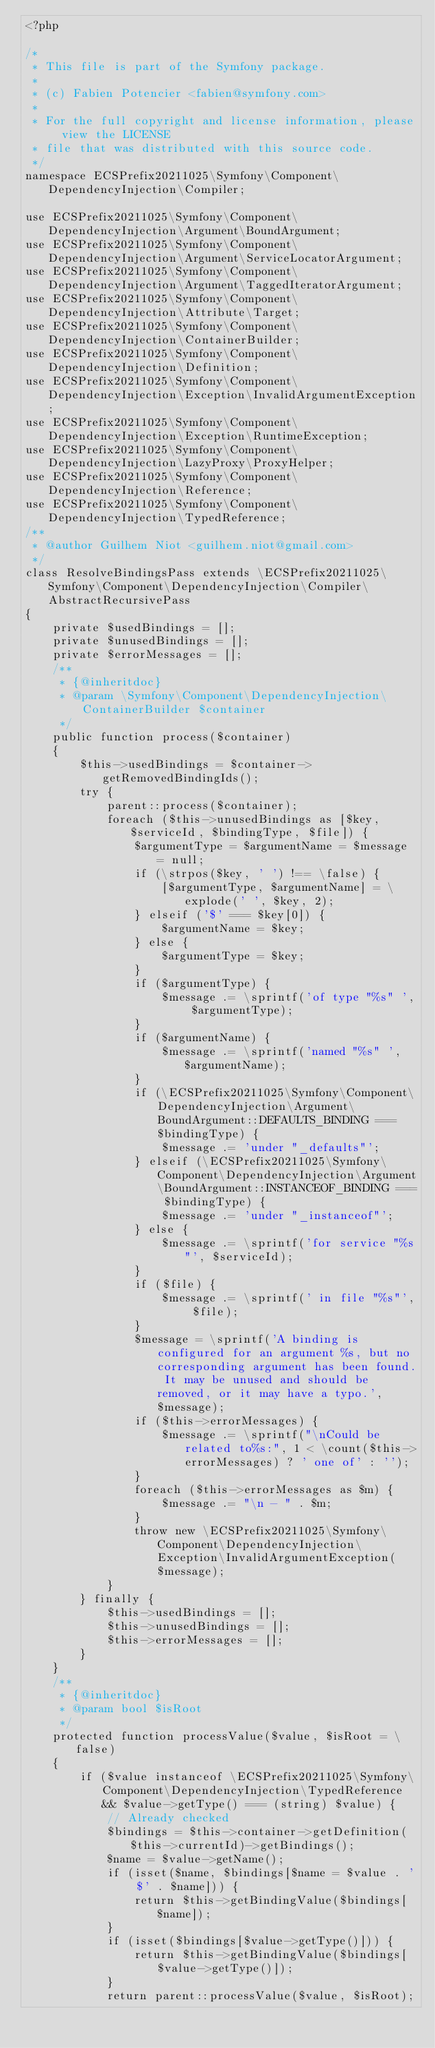Convert code to text. <code><loc_0><loc_0><loc_500><loc_500><_PHP_><?php

/*
 * This file is part of the Symfony package.
 *
 * (c) Fabien Potencier <fabien@symfony.com>
 *
 * For the full copyright and license information, please view the LICENSE
 * file that was distributed with this source code.
 */
namespace ECSPrefix20211025\Symfony\Component\DependencyInjection\Compiler;

use ECSPrefix20211025\Symfony\Component\DependencyInjection\Argument\BoundArgument;
use ECSPrefix20211025\Symfony\Component\DependencyInjection\Argument\ServiceLocatorArgument;
use ECSPrefix20211025\Symfony\Component\DependencyInjection\Argument\TaggedIteratorArgument;
use ECSPrefix20211025\Symfony\Component\DependencyInjection\Attribute\Target;
use ECSPrefix20211025\Symfony\Component\DependencyInjection\ContainerBuilder;
use ECSPrefix20211025\Symfony\Component\DependencyInjection\Definition;
use ECSPrefix20211025\Symfony\Component\DependencyInjection\Exception\InvalidArgumentException;
use ECSPrefix20211025\Symfony\Component\DependencyInjection\Exception\RuntimeException;
use ECSPrefix20211025\Symfony\Component\DependencyInjection\LazyProxy\ProxyHelper;
use ECSPrefix20211025\Symfony\Component\DependencyInjection\Reference;
use ECSPrefix20211025\Symfony\Component\DependencyInjection\TypedReference;
/**
 * @author Guilhem Niot <guilhem.niot@gmail.com>
 */
class ResolveBindingsPass extends \ECSPrefix20211025\Symfony\Component\DependencyInjection\Compiler\AbstractRecursivePass
{
    private $usedBindings = [];
    private $unusedBindings = [];
    private $errorMessages = [];
    /**
     * {@inheritdoc}
     * @param \Symfony\Component\DependencyInjection\ContainerBuilder $container
     */
    public function process($container)
    {
        $this->usedBindings = $container->getRemovedBindingIds();
        try {
            parent::process($container);
            foreach ($this->unusedBindings as [$key, $serviceId, $bindingType, $file]) {
                $argumentType = $argumentName = $message = null;
                if (\strpos($key, ' ') !== \false) {
                    [$argumentType, $argumentName] = \explode(' ', $key, 2);
                } elseif ('$' === $key[0]) {
                    $argumentName = $key;
                } else {
                    $argumentType = $key;
                }
                if ($argumentType) {
                    $message .= \sprintf('of type "%s" ', $argumentType);
                }
                if ($argumentName) {
                    $message .= \sprintf('named "%s" ', $argumentName);
                }
                if (\ECSPrefix20211025\Symfony\Component\DependencyInjection\Argument\BoundArgument::DEFAULTS_BINDING === $bindingType) {
                    $message .= 'under "_defaults"';
                } elseif (\ECSPrefix20211025\Symfony\Component\DependencyInjection\Argument\BoundArgument::INSTANCEOF_BINDING === $bindingType) {
                    $message .= 'under "_instanceof"';
                } else {
                    $message .= \sprintf('for service "%s"', $serviceId);
                }
                if ($file) {
                    $message .= \sprintf(' in file "%s"', $file);
                }
                $message = \sprintf('A binding is configured for an argument %s, but no corresponding argument has been found. It may be unused and should be removed, or it may have a typo.', $message);
                if ($this->errorMessages) {
                    $message .= \sprintf("\nCould be related to%s:", 1 < \count($this->errorMessages) ? ' one of' : '');
                }
                foreach ($this->errorMessages as $m) {
                    $message .= "\n - " . $m;
                }
                throw new \ECSPrefix20211025\Symfony\Component\DependencyInjection\Exception\InvalidArgumentException($message);
            }
        } finally {
            $this->usedBindings = [];
            $this->unusedBindings = [];
            $this->errorMessages = [];
        }
    }
    /**
     * {@inheritdoc}
     * @param bool $isRoot
     */
    protected function processValue($value, $isRoot = \false)
    {
        if ($value instanceof \ECSPrefix20211025\Symfony\Component\DependencyInjection\TypedReference && $value->getType() === (string) $value) {
            // Already checked
            $bindings = $this->container->getDefinition($this->currentId)->getBindings();
            $name = $value->getName();
            if (isset($name, $bindings[$name = $value . ' $' . $name])) {
                return $this->getBindingValue($bindings[$name]);
            }
            if (isset($bindings[$value->getType()])) {
                return $this->getBindingValue($bindings[$value->getType()]);
            }
            return parent::processValue($value, $isRoot);</code> 